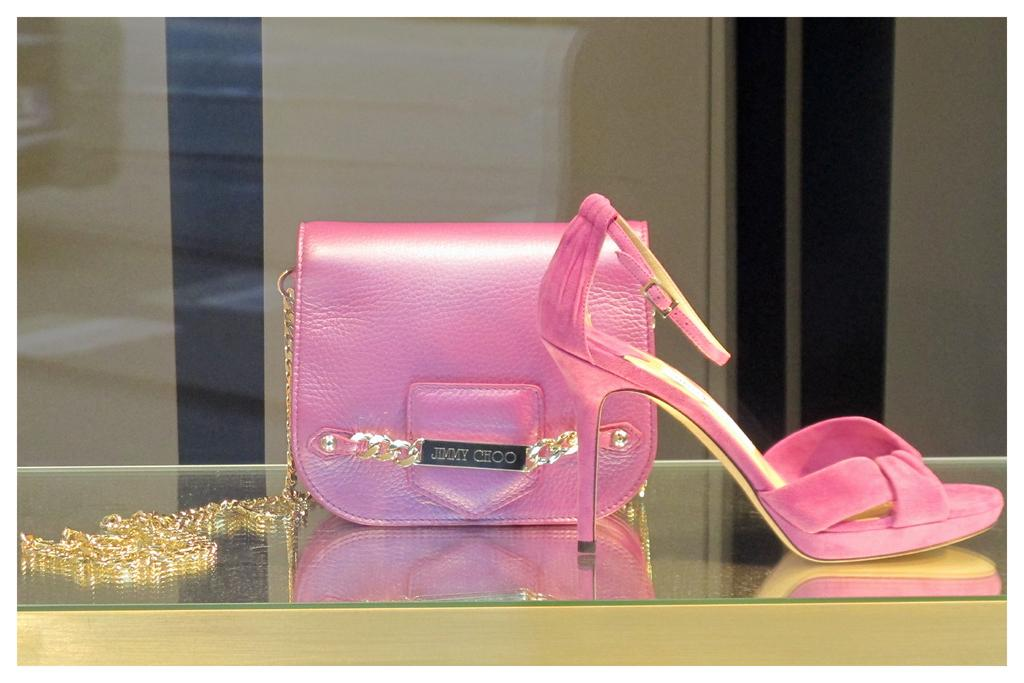What color is the handbag in the image? The handbag in the image is pink. What type of material is the handbag made of? The handbag is made of leather. What other pink item can be seen in the image? There is a pink sandal in the image. Where is the sandal located in relation to the handbag? The sandal is on the right side of the handbag. Can you see any squirrels playing chess on the handbag in the image? There are no squirrels or chess games present on the handbag in the image. 